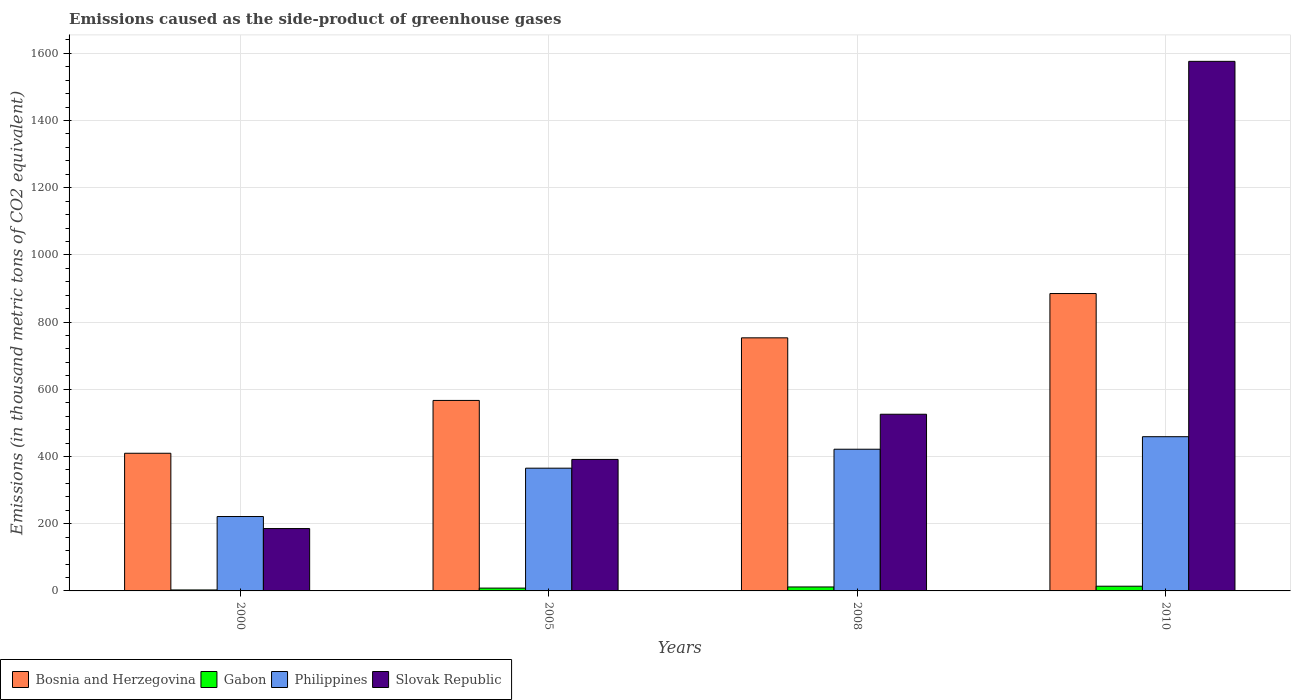How many different coloured bars are there?
Your response must be concise. 4. Are the number of bars on each tick of the X-axis equal?
Offer a terse response. Yes. How many bars are there on the 1st tick from the left?
Provide a short and direct response. 4. What is the emissions caused as the side-product of greenhouse gases in Gabon in 2000?
Ensure brevity in your answer.  2.9. Across all years, what is the maximum emissions caused as the side-product of greenhouse gases in Philippines?
Your answer should be compact. 459. Across all years, what is the minimum emissions caused as the side-product of greenhouse gases in Bosnia and Herzegovina?
Give a very brief answer. 409.7. What is the total emissions caused as the side-product of greenhouse gases in Gabon in the graph?
Give a very brief answer. 37.1. What is the difference between the emissions caused as the side-product of greenhouse gases in Philippines in 2000 and that in 2008?
Give a very brief answer. -200.3. What is the difference between the emissions caused as the side-product of greenhouse gases in Bosnia and Herzegovina in 2000 and the emissions caused as the side-product of greenhouse gases in Philippines in 2005?
Keep it short and to the point. 44.4. What is the average emissions caused as the side-product of greenhouse gases in Gabon per year?
Offer a very short reply. 9.28. In the year 2008, what is the difference between the emissions caused as the side-product of greenhouse gases in Gabon and emissions caused as the side-product of greenhouse gases in Slovak Republic?
Give a very brief answer. -514. In how many years, is the emissions caused as the side-product of greenhouse gases in Gabon greater than 1480 thousand metric tons?
Your answer should be compact. 0. What is the ratio of the emissions caused as the side-product of greenhouse gases in Philippines in 2005 to that in 2008?
Ensure brevity in your answer.  0.87. What is the difference between the highest and the second highest emissions caused as the side-product of greenhouse gases in Bosnia and Herzegovina?
Provide a succinct answer. 131.8. What is the difference between the highest and the lowest emissions caused as the side-product of greenhouse gases in Philippines?
Keep it short and to the point. 237.6. Is the sum of the emissions caused as the side-product of greenhouse gases in Gabon in 2000 and 2010 greater than the maximum emissions caused as the side-product of greenhouse gases in Slovak Republic across all years?
Your response must be concise. No. Is it the case that in every year, the sum of the emissions caused as the side-product of greenhouse gases in Slovak Republic and emissions caused as the side-product of greenhouse gases in Gabon is greater than the sum of emissions caused as the side-product of greenhouse gases in Bosnia and Herzegovina and emissions caused as the side-product of greenhouse gases in Philippines?
Your answer should be very brief. No. What does the 1st bar from the left in 2010 represents?
Give a very brief answer. Bosnia and Herzegovina. What does the 4th bar from the right in 2005 represents?
Give a very brief answer. Bosnia and Herzegovina. How many bars are there?
Provide a short and direct response. 16. How many years are there in the graph?
Provide a succinct answer. 4. What is the difference between two consecutive major ticks on the Y-axis?
Provide a succinct answer. 200. Are the values on the major ticks of Y-axis written in scientific E-notation?
Make the answer very short. No. Does the graph contain any zero values?
Your answer should be compact. No. Does the graph contain grids?
Offer a terse response. Yes. Where does the legend appear in the graph?
Your answer should be very brief. Bottom left. How many legend labels are there?
Your answer should be very brief. 4. What is the title of the graph?
Keep it short and to the point. Emissions caused as the side-product of greenhouse gases. What is the label or title of the X-axis?
Your response must be concise. Years. What is the label or title of the Y-axis?
Give a very brief answer. Emissions (in thousand metric tons of CO2 equivalent). What is the Emissions (in thousand metric tons of CO2 equivalent) of Bosnia and Herzegovina in 2000?
Provide a short and direct response. 409.7. What is the Emissions (in thousand metric tons of CO2 equivalent) in Philippines in 2000?
Offer a very short reply. 221.4. What is the Emissions (in thousand metric tons of CO2 equivalent) of Slovak Republic in 2000?
Give a very brief answer. 185.6. What is the Emissions (in thousand metric tons of CO2 equivalent) of Bosnia and Herzegovina in 2005?
Your answer should be very brief. 566.9. What is the Emissions (in thousand metric tons of CO2 equivalent) in Gabon in 2005?
Your response must be concise. 8.4. What is the Emissions (in thousand metric tons of CO2 equivalent) of Philippines in 2005?
Provide a short and direct response. 365.3. What is the Emissions (in thousand metric tons of CO2 equivalent) in Slovak Republic in 2005?
Your answer should be compact. 391.3. What is the Emissions (in thousand metric tons of CO2 equivalent) of Bosnia and Herzegovina in 2008?
Ensure brevity in your answer.  753.2. What is the Emissions (in thousand metric tons of CO2 equivalent) of Gabon in 2008?
Your answer should be very brief. 11.8. What is the Emissions (in thousand metric tons of CO2 equivalent) in Philippines in 2008?
Your answer should be compact. 421.7. What is the Emissions (in thousand metric tons of CO2 equivalent) in Slovak Republic in 2008?
Provide a succinct answer. 525.8. What is the Emissions (in thousand metric tons of CO2 equivalent) in Bosnia and Herzegovina in 2010?
Provide a succinct answer. 885. What is the Emissions (in thousand metric tons of CO2 equivalent) of Gabon in 2010?
Offer a terse response. 14. What is the Emissions (in thousand metric tons of CO2 equivalent) of Philippines in 2010?
Offer a very short reply. 459. What is the Emissions (in thousand metric tons of CO2 equivalent) in Slovak Republic in 2010?
Your answer should be compact. 1576. Across all years, what is the maximum Emissions (in thousand metric tons of CO2 equivalent) in Bosnia and Herzegovina?
Offer a very short reply. 885. Across all years, what is the maximum Emissions (in thousand metric tons of CO2 equivalent) of Gabon?
Offer a terse response. 14. Across all years, what is the maximum Emissions (in thousand metric tons of CO2 equivalent) of Philippines?
Provide a succinct answer. 459. Across all years, what is the maximum Emissions (in thousand metric tons of CO2 equivalent) in Slovak Republic?
Your response must be concise. 1576. Across all years, what is the minimum Emissions (in thousand metric tons of CO2 equivalent) in Bosnia and Herzegovina?
Offer a terse response. 409.7. Across all years, what is the minimum Emissions (in thousand metric tons of CO2 equivalent) of Philippines?
Provide a succinct answer. 221.4. Across all years, what is the minimum Emissions (in thousand metric tons of CO2 equivalent) in Slovak Republic?
Your answer should be compact. 185.6. What is the total Emissions (in thousand metric tons of CO2 equivalent) of Bosnia and Herzegovina in the graph?
Offer a very short reply. 2614.8. What is the total Emissions (in thousand metric tons of CO2 equivalent) of Gabon in the graph?
Your answer should be very brief. 37.1. What is the total Emissions (in thousand metric tons of CO2 equivalent) of Philippines in the graph?
Ensure brevity in your answer.  1467.4. What is the total Emissions (in thousand metric tons of CO2 equivalent) in Slovak Republic in the graph?
Make the answer very short. 2678.7. What is the difference between the Emissions (in thousand metric tons of CO2 equivalent) in Bosnia and Herzegovina in 2000 and that in 2005?
Make the answer very short. -157.2. What is the difference between the Emissions (in thousand metric tons of CO2 equivalent) in Philippines in 2000 and that in 2005?
Your answer should be very brief. -143.9. What is the difference between the Emissions (in thousand metric tons of CO2 equivalent) in Slovak Republic in 2000 and that in 2005?
Offer a terse response. -205.7. What is the difference between the Emissions (in thousand metric tons of CO2 equivalent) of Bosnia and Herzegovina in 2000 and that in 2008?
Offer a very short reply. -343.5. What is the difference between the Emissions (in thousand metric tons of CO2 equivalent) in Gabon in 2000 and that in 2008?
Your answer should be very brief. -8.9. What is the difference between the Emissions (in thousand metric tons of CO2 equivalent) in Philippines in 2000 and that in 2008?
Provide a succinct answer. -200.3. What is the difference between the Emissions (in thousand metric tons of CO2 equivalent) of Slovak Republic in 2000 and that in 2008?
Your answer should be compact. -340.2. What is the difference between the Emissions (in thousand metric tons of CO2 equivalent) of Bosnia and Herzegovina in 2000 and that in 2010?
Give a very brief answer. -475.3. What is the difference between the Emissions (in thousand metric tons of CO2 equivalent) in Philippines in 2000 and that in 2010?
Ensure brevity in your answer.  -237.6. What is the difference between the Emissions (in thousand metric tons of CO2 equivalent) in Slovak Republic in 2000 and that in 2010?
Your response must be concise. -1390.4. What is the difference between the Emissions (in thousand metric tons of CO2 equivalent) in Bosnia and Herzegovina in 2005 and that in 2008?
Your answer should be compact. -186.3. What is the difference between the Emissions (in thousand metric tons of CO2 equivalent) of Philippines in 2005 and that in 2008?
Give a very brief answer. -56.4. What is the difference between the Emissions (in thousand metric tons of CO2 equivalent) of Slovak Republic in 2005 and that in 2008?
Your response must be concise. -134.5. What is the difference between the Emissions (in thousand metric tons of CO2 equivalent) in Bosnia and Herzegovina in 2005 and that in 2010?
Give a very brief answer. -318.1. What is the difference between the Emissions (in thousand metric tons of CO2 equivalent) of Gabon in 2005 and that in 2010?
Your answer should be very brief. -5.6. What is the difference between the Emissions (in thousand metric tons of CO2 equivalent) in Philippines in 2005 and that in 2010?
Keep it short and to the point. -93.7. What is the difference between the Emissions (in thousand metric tons of CO2 equivalent) in Slovak Republic in 2005 and that in 2010?
Keep it short and to the point. -1184.7. What is the difference between the Emissions (in thousand metric tons of CO2 equivalent) in Bosnia and Herzegovina in 2008 and that in 2010?
Ensure brevity in your answer.  -131.8. What is the difference between the Emissions (in thousand metric tons of CO2 equivalent) in Philippines in 2008 and that in 2010?
Ensure brevity in your answer.  -37.3. What is the difference between the Emissions (in thousand metric tons of CO2 equivalent) in Slovak Republic in 2008 and that in 2010?
Give a very brief answer. -1050.2. What is the difference between the Emissions (in thousand metric tons of CO2 equivalent) of Bosnia and Herzegovina in 2000 and the Emissions (in thousand metric tons of CO2 equivalent) of Gabon in 2005?
Give a very brief answer. 401.3. What is the difference between the Emissions (in thousand metric tons of CO2 equivalent) of Bosnia and Herzegovina in 2000 and the Emissions (in thousand metric tons of CO2 equivalent) of Philippines in 2005?
Make the answer very short. 44.4. What is the difference between the Emissions (in thousand metric tons of CO2 equivalent) of Bosnia and Herzegovina in 2000 and the Emissions (in thousand metric tons of CO2 equivalent) of Slovak Republic in 2005?
Keep it short and to the point. 18.4. What is the difference between the Emissions (in thousand metric tons of CO2 equivalent) of Gabon in 2000 and the Emissions (in thousand metric tons of CO2 equivalent) of Philippines in 2005?
Provide a short and direct response. -362.4. What is the difference between the Emissions (in thousand metric tons of CO2 equivalent) of Gabon in 2000 and the Emissions (in thousand metric tons of CO2 equivalent) of Slovak Republic in 2005?
Your answer should be compact. -388.4. What is the difference between the Emissions (in thousand metric tons of CO2 equivalent) in Philippines in 2000 and the Emissions (in thousand metric tons of CO2 equivalent) in Slovak Republic in 2005?
Your response must be concise. -169.9. What is the difference between the Emissions (in thousand metric tons of CO2 equivalent) of Bosnia and Herzegovina in 2000 and the Emissions (in thousand metric tons of CO2 equivalent) of Gabon in 2008?
Provide a short and direct response. 397.9. What is the difference between the Emissions (in thousand metric tons of CO2 equivalent) in Bosnia and Herzegovina in 2000 and the Emissions (in thousand metric tons of CO2 equivalent) in Philippines in 2008?
Ensure brevity in your answer.  -12. What is the difference between the Emissions (in thousand metric tons of CO2 equivalent) in Bosnia and Herzegovina in 2000 and the Emissions (in thousand metric tons of CO2 equivalent) in Slovak Republic in 2008?
Provide a succinct answer. -116.1. What is the difference between the Emissions (in thousand metric tons of CO2 equivalent) of Gabon in 2000 and the Emissions (in thousand metric tons of CO2 equivalent) of Philippines in 2008?
Your response must be concise. -418.8. What is the difference between the Emissions (in thousand metric tons of CO2 equivalent) in Gabon in 2000 and the Emissions (in thousand metric tons of CO2 equivalent) in Slovak Republic in 2008?
Your answer should be compact. -522.9. What is the difference between the Emissions (in thousand metric tons of CO2 equivalent) in Philippines in 2000 and the Emissions (in thousand metric tons of CO2 equivalent) in Slovak Republic in 2008?
Your answer should be very brief. -304.4. What is the difference between the Emissions (in thousand metric tons of CO2 equivalent) of Bosnia and Herzegovina in 2000 and the Emissions (in thousand metric tons of CO2 equivalent) of Gabon in 2010?
Your answer should be compact. 395.7. What is the difference between the Emissions (in thousand metric tons of CO2 equivalent) of Bosnia and Herzegovina in 2000 and the Emissions (in thousand metric tons of CO2 equivalent) of Philippines in 2010?
Ensure brevity in your answer.  -49.3. What is the difference between the Emissions (in thousand metric tons of CO2 equivalent) of Bosnia and Herzegovina in 2000 and the Emissions (in thousand metric tons of CO2 equivalent) of Slovak Republic in 2010?
Make the answer very short. -1166.3. What is the difference between the Emissions (in thousand metric tons of CO2 equivalent) in Gabon in 2000 and the Emissions (in thousand metric tons of CO2 equivalent) in Philippines in 2010?
Your answer should be compact. -456.1. What is the difference between the Emissions (in thousand metric tons of CO2 equivalent) in Gabon in 2000 and the Emissions (in thousand metric tons of CO2 equivalent) in Slovak Republic in 2010?
Your answer should be very brief. -1573.1. What is the difference between the Emissions (in thousand metric tons of CO2 equivalent) of Philippines in 2000 and the Emissions (in thousand metric tons of CO2 equivalent) of Slovak Republic in 2010?
Your response must be concise. -1354.6. What is the difference between the Emissions (in thousand metric tons of CO2 equivalent) of Bosnia and Herzegovina in 2005 and the Emissions (in thousand metric tons of CO2 equivalent) of Gabon in 2008?
Make the answer very short. 555.1. What is the difference between the Emissions (in thousand metric tons of CO2 equivalent) in Bosnia and Herzegovina in 2005 and the Emissions (in thousand metric tons of CO2 equivalent) in Philippines in 2008?
Provide a short and direct response. 145.2. What is the difference between the Emissions (in thousand metric tons of CO2 equivalent) in Bosnia and Herzegovina in 2005 and the Emissions (in thousand metric tons of CO2 equivalent) in Slovak Republic in 2008?
Give a very brief answer. 41.1. What is the difference between the Emissions (in thousand metric tons of CO2 equivalent) of Gabon in 2005 and the Emissions (in thousand metric tons of CO2 equivalent) of Philippines in 2008?
Make the answer very short. -413.3. What is the difference between the Emissions (in thousand metric tons of CO2 equivalent) in Gabon in 2005 and the Emissions (in thousand metric tons of CO2 equivalent) in Slovak Republic in 2008?
Offer a very short reply. -517.4. What is the difference between the Emissions (in thousand metric tons of CO2 equivalent) in Philippines in 2005 and the Emissions (in thousand metric tons of CO2 equivalent) in Slovak Republic in 2008?
Offer a very short reply. -160.5. What is the difference between the Emissions (in thousand metric tons of CO2 equivalent) of Bosnia and Herzegovina in 2005 and the Emissions (in thousand metric tons of CO2 equivalent) of Gabon in 2010?
Offer a very short reply. 552.9. What is the difference between the Emissions (in thousand metric tons of CO2 equivalent) in Bosnia and Herzegovina in 2005 and the Emissions (in thousand metric tons of CO2 equivalent) in Philippines in 2010?
Ensure brevity in your answer.  107.9. What is the difference between the Emissions (in thousand metric tons of CO2 equivalent) in Bosnia and Herzegovina in 2005 and the Emissions (in thousand metric tons of CO2 equivalent) in Slovak Republic in 2010?
Your answer should be compact. -1009.1. What is the difference between the Emissions (in thousand metric tons of CO2 equivalent) of Gabon in 2005 and the Emissions (in thousand metric tons of CO2 equivalent) of Philippines in 2010?
Provide a short and direct response. -450.6. What is the difference between the Emissions (in thousand metric tons of CO2 equivalent) in Gabon in 2005 and the Emissions (in thousand metric tons of CO2 equivalent) in Slovak Republic in 2010?
Your answer should be very brief. -1567.6. What is the difference between the Emissions (in thousand metric tons of CO2 equivalent) in Philippines in 2005 and the Emissions (in thousand metric tons of CO2 equivalent) in Slovak Republic in 2010?
Offer a terse response. -1210.7. What is the difference between the Emissions (in thousand metric tons of CO2 equivalent) in Bosnia and Herzegovina in 2008 and the Emissions (in thousand metric tons of CO2 equivalent) in Gabon in 2010?
Your response must be concise. 739.2. What is the difference between the Emissions (in thousand metric tons of CO2 equivalent) in Bosnia and Herzegovina in 2008 and the Emissions (in thousand metric tons of CO2 equivalent) in Philippines in 2010?
Ensure brevity in your answer.  294.2. What is the difference between the Emissions (in thousand metric tons of CO2 equivalent) in Bosnia and Herzegovina in 2008 and the Emissions (in thousand metric tons of CO2 equivalent) in Slovak Republic in 2010?
Provide a succinct answer. -822.8. What is the difference between the Emissions (in thousand metric tons of CO2 equivalent) of Gabon in 2008 and the Emissions (in thousand metric tons of CO2 equivalent) of Philippines in 2010?
Give a very brief answer. -447.2. What is the difference between the Emissions (in thousand metric tons of CO2 equivalent) of Gabon in 2008 and the Emissions (in thousand metric tons of CO2 equivalent) of Slovak Republic in 2010?
Make the answer very short. -1564.2. What is the difference between the Emissions (in thousand metric tons of CO2 equivalent) in Philippines in 2008 and the Emissions (in thousand metric tons of CO2 equivalent) in Slovak Republic in 2010?
Your answer should be very brief. -1154.3. What is the average Emissions (in thousand metric tons of CO2 equivalent) of Bosnia and Herzegovina per year?
Make the answer very short. 653.7. What is the average Emissions (in thousand metric tons of CO2 equivalent) in Gabon per year?
Your response must be concise. 9.28. What is the average Emissions (in thousand metric tons of CO2 equivalent) of Philippines per year?
Your answer should be compact. 366.85. What is the average Emissions (in thousand metric tons of CO2 equivalent) in Slovak Republic per year?
Ensure brevity in your answer.  669.67. In the year 2000, what is the difference between the Emissions (in thousand metric tons of CO2 equivalent) of Bosnia and Herzegovina and Emissions (in thousand metric tons of CO2 equivalent) of Gabon?
Provide a short and direct response. 406.8. In the year 2000, what is the difference between the Emissions (in thousand metric tons of CO2 equivalent) of Bosnia and Herzegovina and Emissions (in thousand metric tons of CO2 equivalent) of Philippines?
Provide a short and direct response. 188.3. In the year 2000, what is the difference between the Emissions (in thousand metric tons of CO2 equivalent) in Bosnia and Herzegovina and Emissions (in thousand metric tons of CO2 equivalent) in Slovak Republic?
Ensure brevity in your answer.  224.1. In the year 2000, what is the difference between the Emissions (in thousand metric tons of CO2 equivalent) in Gabon and Emissions (in thousand metric tons of CO2 equivalent) in Philippines?
Offer a very short reply. -218.5. In the year 2000, what is the difference between the Emissions (in thousand metric tons of CO2 equivalent) of Gabon and Emissions (in thousand metric tons of CO2 equivalent) of Slovak Republic?
Make the answer very short. -182.7. In the year 2000, what is the difference between the Emissions (in thousand metric tons of CO2 equivalent) of Philippines and Emissions (in thousand metric tons of CO2 equivalent) of Slovak Republic?
Your answer should be compact. 35.8. In the year 2005, what is the difference between the Emissions (in thousand metric tons of CO2 equivalent) of Bosnia and Herzegovina and Emissions (in thousand metric tons of CO2 equivalent) of Gabon?
Offer a very short reply. 558.5. In the year 2005, what is the difference between the Emissions (in thousand metric tons of CO2 equivalent) of Bosnia and Herzegovina and Emissions (in thousand metric tons of CO2 equivalent) of Philippines?
Keep it short and to the point. 201.6. In the year 2005, what is the difference between the Emissions (in thousand metric tons of CO2 equivalent) of Bosnia and Herzegovina and Emissions (in thousand metric tons of CO2 equivalent) of Slovak Republic?
Your answer should be compact. 175.6. In the year 2005, what is the difference between the Emissions (in thousand metric tons of CO2 equivalent) in Gabon and Emissions (in thousand metric tons of CO2 equivalent) in Philippines?
Offer a very short reply. -356.9. In the year 2005, what is the difference between the Emissions (in thousand metric tons of CO2 equivalent) in Gabon and Emissions (in thousand metric tons of CO2 equivalent) in Slovak Republic?
Make the answer very short. -382.9. In the year 2008, what is the difference between the Emissions (in thousand metric tons of CO2 equivalent) of Bosnia and Herzegovina and Emissions (in thousand metric tons of CO2 equivalent) of Gabon?
Provide a short and direct response. 741.4. In the year 2008, what is the difference between the Emissions (in thousand metric tons of CO2 equivalent) in Bosnia and Herzegovina and Emissions (in thousand metric tons of CO2 equivalent) in Philippines?
Offer a terse response. 331.5. In the year 2008, what is the difference between the Emissions (in thousand metric tons of CO2 equivalent) of Bosnia and Herzegovina and Emissions (in thousand metric tons of CO2 equivalent) of Slovak Republic?
Give a very brief answer. 227.4. In the year 2008, what is the difference between the Emissions (in thousand metric tons of CO2 equivalent) of Gabon and Emissions (in thousand metric tons of CO2 equivalent) of Philippines?
Your answer should be very brief. -409.9. In the year 2008, what is the difference between the Emissions (in thousand metric tons of CO2 equivalent) of Gabon and Emissions (in thousand metric tons of CO2 equivalent) of Slovak Republic?
Offer a very short reply. -514. In the year 2008, what is the difference between the Emissions (in thousand metric tons of CO2 equivalent) in Philippines and Emissions (in thousand metric tons of CO2 equivalent) in Slovak Republic?
Make the answer very short. -104.1. In the year 2010, what is the difference between the Emissions (in thousand metric tons of CO2 equivalent) in Bosnia and Herzegovina and Emissions (in thousand metric tons of CO2 equivalent) in Gabon?
Your answer should be compact. 871. In the year 2010, what is the difference between the Emissions (in thousand metric tons of CO2 equivalent) of Bosnia and Herzegovina and Emissions (in thousand metric tons of CO2 equivalent) of Philippines?
Offer a terse response. 426. In the year 2010, what is the difference between the Emissions (in thousand metric tons of CO2 equivalent) in Bosnia and Herzegovina and Emissions (in thousand metric tons of CO2 equivalent) in Slovak Republic?
Offer a terse response. -691. In the year 2010, what is the difference between the Emissions (in thousand metric tons of CO2 equivalent) of Gabon and Emissions (in thousand metric tons of CO2 equivalent) of Philippines?
Provide a short and direct response. -445. In the year 2010, what is the difference between the Emissions (in thousand metric tons of CO2 equivalent) of Gabon and Emissions (in thousand metric tons of CO2 equivalent) of Slovak Republic?
Give a very brief answer. -1562. In the year 2010, what is the difference between the Emissions (in thousand metric tons of CO2 equivalent) in Philippines and Emissions (in thousand metric tons of CO2 equivalent) in Slovak Republic?
Ensure brevity in your answer.  -1117. What is the ratio of the Emissions (in thousand metric tons of CO2 equivalent) of Bosnia and Herzegovina in 2000 to that in 2005?
Ensure brevity in your answer.  0.72. What is the ratio of the Emissions (in thousand metric tons of CO2 equivalent) in Gabon in 2000 to that in 2005?
Provide a short and direct response. 0.35. What is the ratio of the Emissions (in thousand metric tons of CO2 equivalent) of Philippines in 2000 to that in 2005?
Keep it short and to the point. 0.61. What is the ratio of the Emissions (in thousand metric tons of CO2 equivalent) of Slovak Republic in 2000 to that in 2005?
Ensure brevity in your answer.  0.47. What is the ratio of the Emissions (in thousand metric tons of CO2 equivalent) in Bosnia and Herzegovina in 2000 to that in 2008?
Your response must be concise. 0.54. What is the ratio of the Emissions (in thousand metric tons of CO2 equivalent) in Gabon in 2000 to that in 2008?
Your response must be concise. 0.25. What is the ratio of the Emissions (in thousand metric tons of CO2 equivalent) in Philippines in 2000 to that in 2008?
Provide a succinct answer. 0.53. What is the ratio of the Emissions (in thousand metric tons of CO2 equivalent) in Slovak Republic in 2000 to that in 2008?
Offer a terse response. 0.35. What is the ratio of the Emissions (in thousand metric tons of CO2 equivalent) of Bosnia and Herzegovina in 2000 to that in 2010?
Your answer should be very brief. 0.46. What is the ratio of the Emissions (in thousand metric tons of CO2 equivalent) of Gabon in 2000 to that in 2010?
Your response must be concise. 0.21. What is the ratio of the Emissions (in thousand metric tons of CO2 equivalent) of Philippines in 2000 to that in 2010?
Your answer should be very brief. 0.48. What is the ratio of the Emissions (in thousand metric tons of CO2 equivalent) in Slovak Republic in 2000 to that in 2010?
Give a very brief answer. 0.12. What is the ratio of the Emissions (in thousand metric tons of CO2 equivalent) in Bosnia and Herzegovina in 2005 to that in 2008?
Offer a terse response. 0.75. What is the ratio of the Emissions (in thousand metric tons of CO2 equivalent) in Gabon in 2005 to that in 2008?
Provide a succinct answer. 0.71. What is the ratio of the Emissions (in thousand metric tons of CO2 equivalent) in Philippines in 2005 to that in 2008?
Make the answer very short. 0.87. What is the ratio of the Emissions (in thousand metric tons of CO2 equivalent) of Slovak Republic in 2005 to that in 2008?
Offer a terse response. 0.74. What is the ratio of the Emissions (in thousand metric tons of CO2 equivalent) of Bosnia and Herzegovina in 2005 to that in 2010?
Provide a short and direct response. 0.64. What is the ratio of the Emissions (in thousand metric tons of CO2 equivalent) of Philippines in 2005 to that in 2010?
Provide a succinct answer. 0.8. What is the ratio of the Emissions (in thousand metric tons of CO2 equivalent) of Slovak Republic in 2005 to that in 2010?
Ensure brevity in your answer.  0.25. What is the ratio of the Emissions (in thousand metric tons of CO2 equivalent) of Bosnia and Herzegovina in 2008 to that in 2010?
Ensure brevity in your answer.  0.85. What is the ratio of the Emissions (in thousand metric tons of CO2 equivalent) of Gabon in 2008 to that in 2010?
Make the answer very short. 0.84. What is the ratio of the Emissions (in thousand metric tons of CO2 equivalent) in Philippines in 2008 to that in 2010?
Your answer should be very brief. 0.92. What is the ratio of the Emissions (in thousand metric tons of CO2 equivalent) of Slovak Republic in 2008 to that in 2010?
Provide a short and direct response. 0.33. What is the difference between the highest and the second highest Emissions (in thousand metric tons of CO2 equivalent) of Bosnia and Herzegovina?
Provide a succinct answer. 131.8. What is the difference between the highest and the second highest Emissions (in thousand metric tons of CO2 equivalent) in Gabon?
Your response must be concise. 2.2. What is the difference between the highest and the second highest Emissions (in thousand metric tons of CO2 equivalent) of Philippines?
Your response must be concise. 37.3. What is the difference between the highest and the second highest Emissions (in thousand metric tons of CO2 equivalent) in Slovak Republic?
Offer a very short reply. 1050.2. What is the difference between the highest and the lowest Emissions (in thousand metric tons of CO2 equivalent) of Bosnia and Herzegovina?
Your answer should be very brief. 475.3. What is the difference between the highest and the lowest Emissions (in thousand metric tons of CO2 equivalent) in Gabon?
Provide a short and direct response. 11.1. What is the difference between the highest and the lowest Emissions (in thousand metric tons of CO2 equivalent) of Philippines?
Offer a very short reply. 237.6. What is the difference between the highest and the lowest Emissions (in thousand metric tons of CO2 equivalent) in Slovak Republic?
Ensure brevity in your answer.  1390.4. 